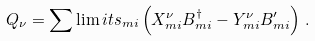Convert formula to latex. <formula><loc_0><loc_0><loc_500><loc_500>Q _ { \nu } = \sum \lim i t s _ { m i } \left ( X ^ { \nu } _ { m i } B ^ { \dagger } _ { m i } - Y ^ { \nu } _ { m i } B ^ { \prime } _ { m i } \right ) \, .</formula> 